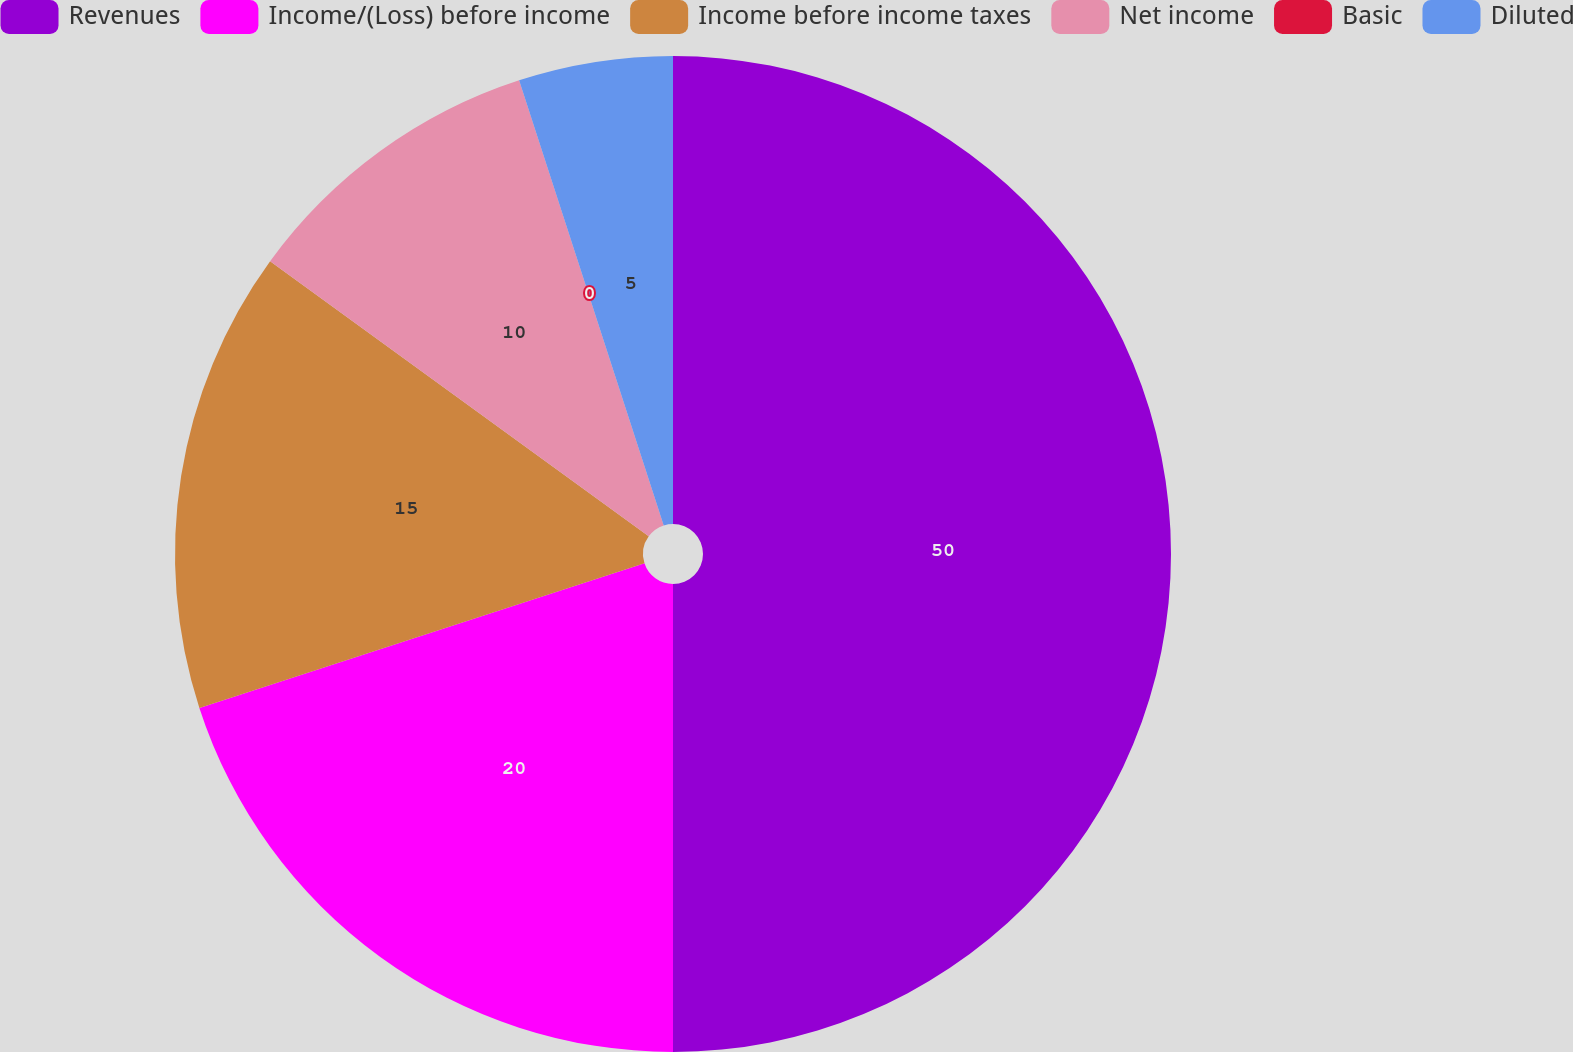Convert chart to OTSL. <chart><loc_0><loc_0><loc_500><loc_500><pie_chart><fcel>Revenues<fcel>Income/(Loss) before income<fcel>Income before income taxes<fcel>Net income<fcel>Basic<fcel>Diluted<nl><fcel>50.0%<fcel>20.0%<fcel>15.0%<fcel>10.0%<fcel>0.0%<fcel>5.0%<nl></chart> 